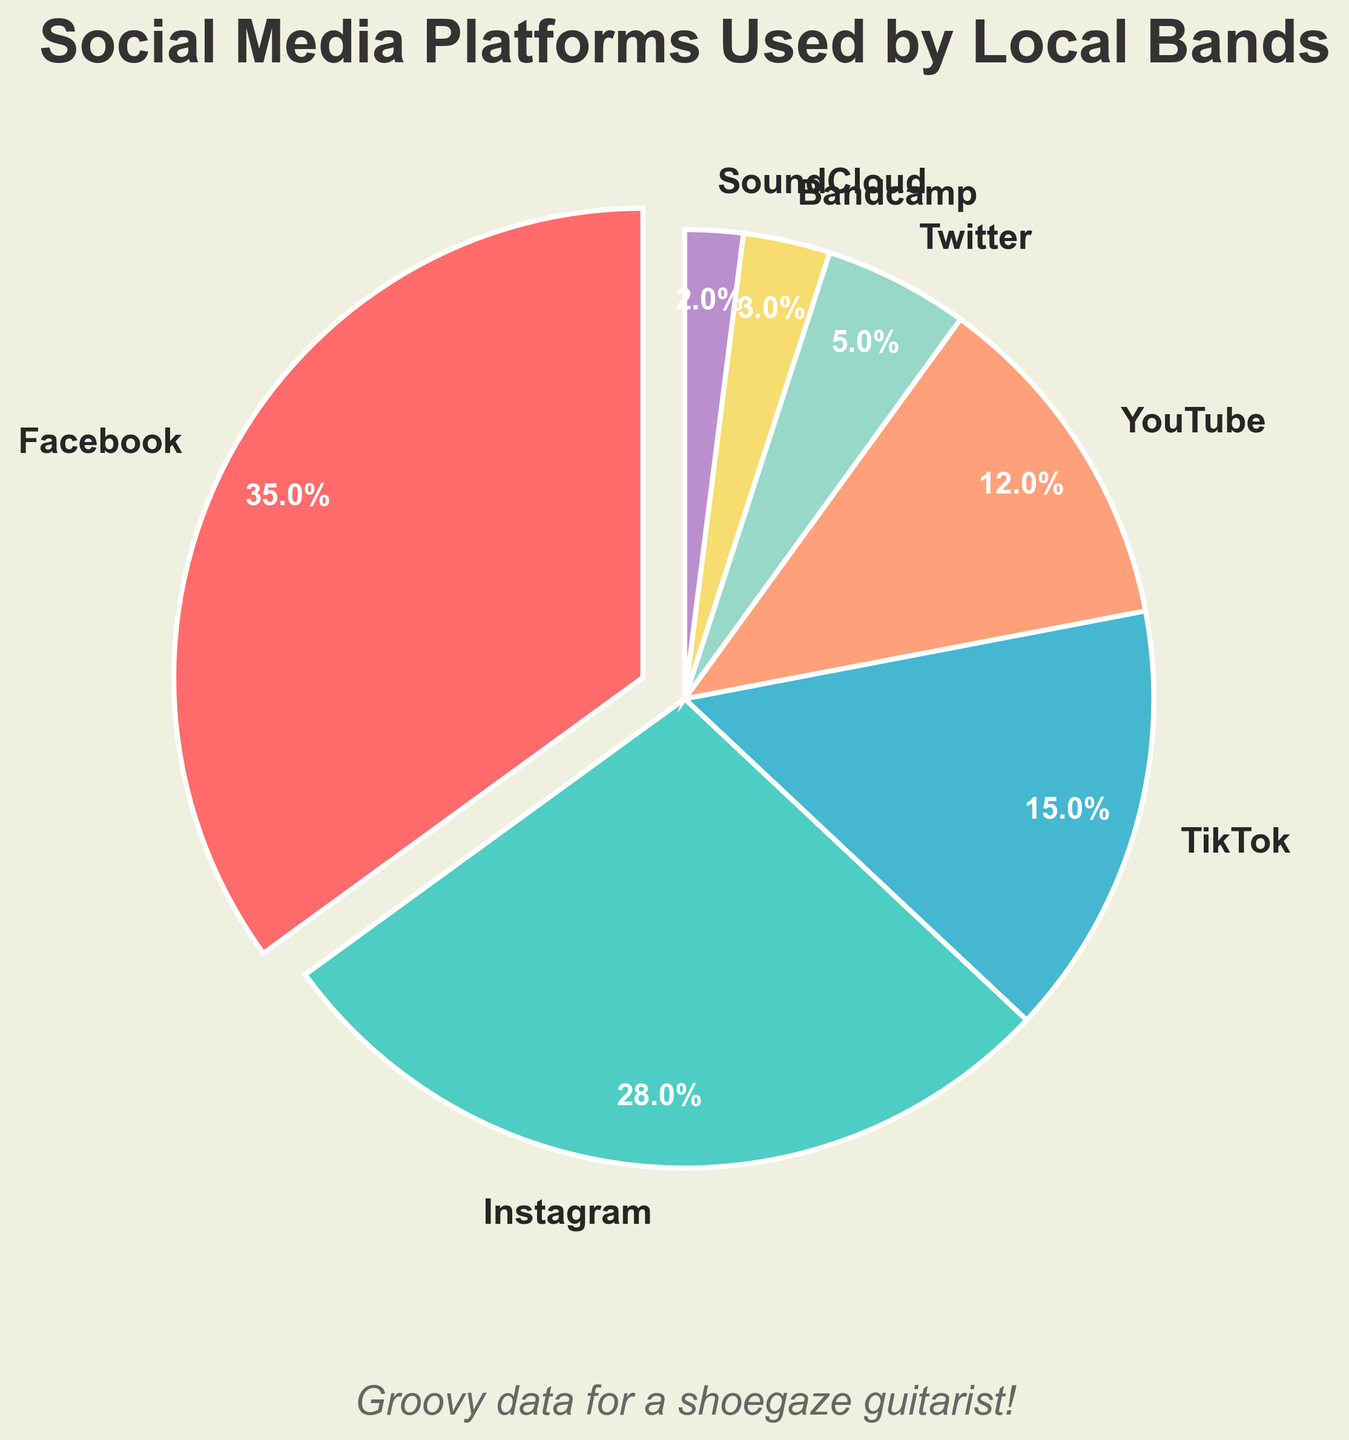What's the most used social media platform for promotion by local bands? The figure shows the percentage share of each social media platform used. The largest pie slice represents Facebook, which is used by 35% of the local bands.
Answer: Facebook Which social media platforms have a share of less than 10%? Observing the figure, the platforms with very small slices are Twitter, Bandcamp, and SoundCloud. Their shares are 5%, 3%, and 2% respectively.
Answer: Twitter, Bandcamp, SoundCloud How much more popular is Instagram compared to YouTube? Instagram's slice shows 28%, while YouTube's slice shows 12%. The difference between percentages is 28% - 12% = 16%.
Answer: 16% Which platform has the smallest share, and what is its percentage? The smallest slice in the figure belongs to SoundCloud, which has a 2% share.
Answer: SoundCloud, 2% What is the combined percentage share of TikTok and YouTube? From the pie chart, TikTok has a 15% share and YouTube has a 12% share. Adding them together gives 15% + 12% = 27%.
Answer: 27% By how much does Facebook lead over Twitter in percentage points? Facebook has a 35% share and Twitter has a 5% share. Subtracting these gives 35% - 5% = 30%.
Answer: 30% Which platforms have shares that are greater than 20%? Observing the pie chart, Facebook has 35% and Instagram has 28%, both of which are greater than 20%.
Answer: Facebook, Instagram How does the share of Bandcamp compare to the share of Instagram? Bandcamp has a 3% share while Instagram has a 28% share. Bandcamp's share is 28% - 3% = 25% less than Instagram's share.
Answer: 25% less What is the total share of platforms other than Facebook, Instagram, and TikTok? Adding the shares of YouTube (12%), Twitter (5%), Bandcamp (3%), and SoundCloud (2%) gives 12% + 5% + 3% + 2% = 22%.
Answer: 22% How many platforms have a share of 5% or less, and which are they? The platforms listed in the pie chart with shares of 5% or less are Twitter (5%), Bandcamp (3%), and SoundCloud (2%). Thus, there are three such platforms.
Answer: 3, Twitter, Bandcamp, SoundCloud 